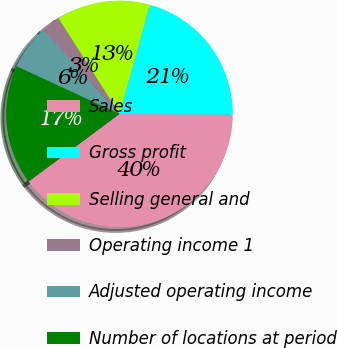Convert chart to OTSL. <chart><loc_0><loc_0><loc_500><loc_500><pie_chart><fcel>Sales<fcel>Gross profit<fcel>Selling general and<fcel>Operating income 1<fcel>Adjusted operating income<fcel>Number of locations at period<nl><fcel>39.73%<fcel>20.78%<fcel>13.37%<fcel>2.67%<fcel>6.37%<fcel>17.08%<nl></chart> 